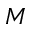Convert formula to latex. <formula><loc_0><loc_0><loc_500><loc_500>M</formula> 